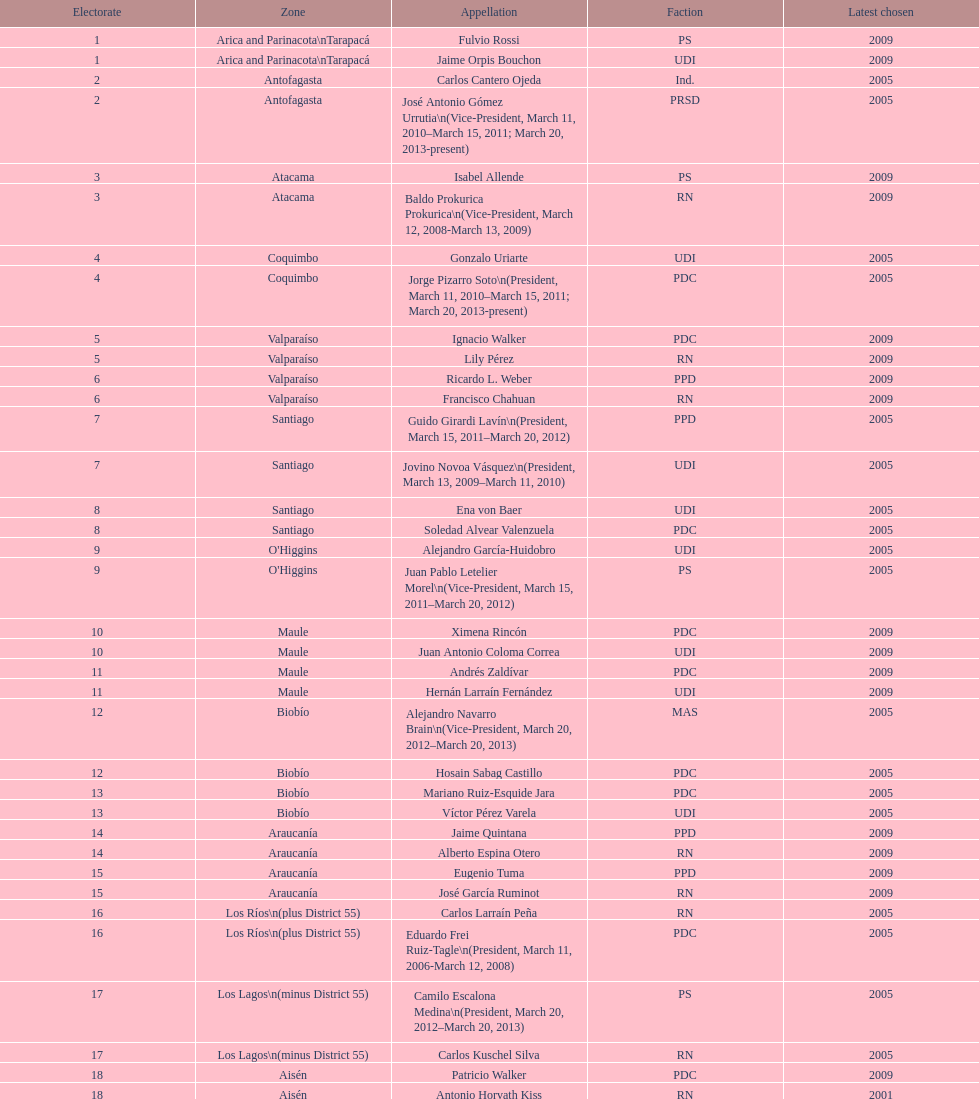How many total consituency are listed in the table? 19. 